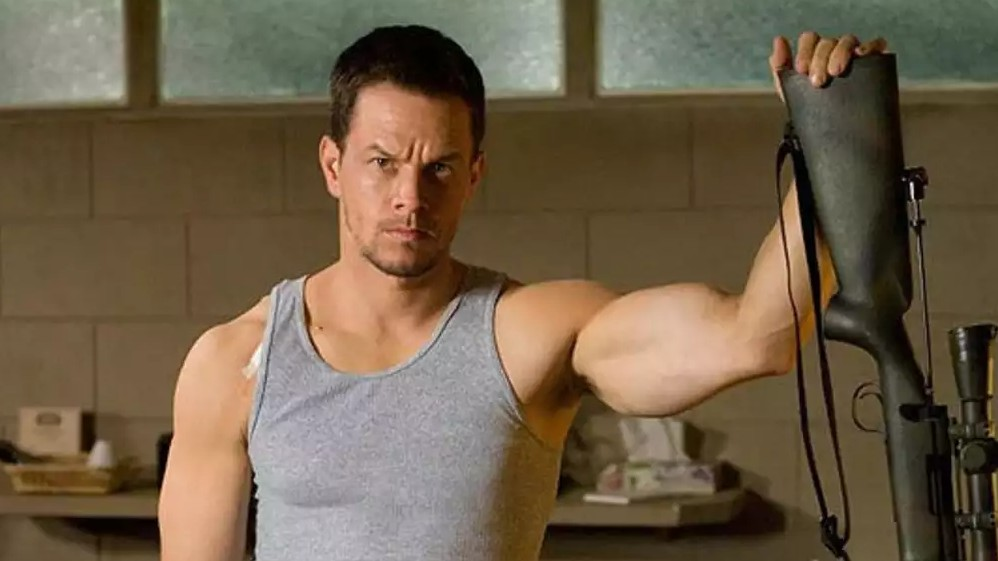What if the character in the image is actually an undercover spy in the middle of a covert operation? If the character is an undercover spy, he is deep within enemy territory, posing as a fitness trainer. The room, seemingly ordinary, is a front for his covert operations. Behind the mundane facade is a full suite of espionage equipment, hidden within the walls and furniture. The gun he holds is not just a firearm but a high-tech gadget with multiple functions, including surveillance and communication. His intense demeanor reflects the high stakes of his mission – gathering crucial intelligence to thwart a terrorist plot. The tension etched on his face reveals the gravity of his next move, which could mean the difference between success and catastrophic failure. 